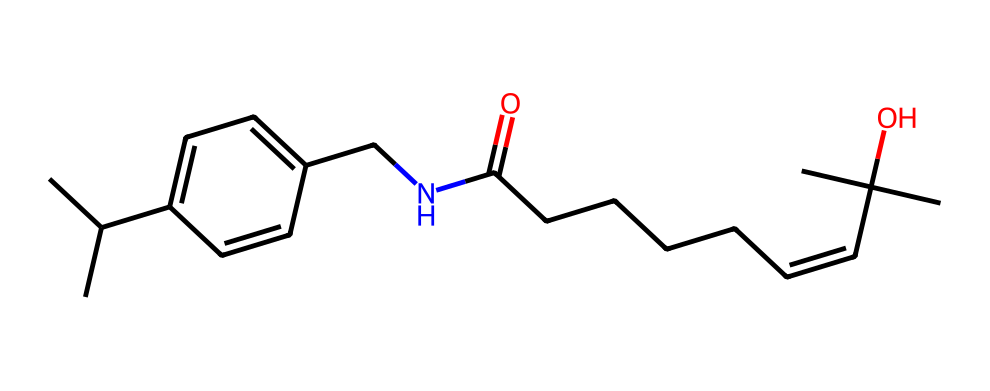What is the total number of carbon atoms in this compound? By inspecting the chemical structure represented in the SMILES, we can count the carbon (C) atoms. Each “C” in the SMILES indicates one carbon atom, and surrounding structures also indicate carbons in the ring and side chains. Upon counting, we find there are 17 carbon atoms total.
Answer: 17 How many nitrogen atoms does capsaicin contain? In the provided SMILES, the nitrogen (N) atom is explicitly represented. By examining the structure, we identify one nitrogen atom present in the amide functional group (CNC).
Answer: 1 Does this compound feature a double bond? The presence of a double bond can be determined by recognizing the “=” symbol in the SMILES notation. In capsaicin's structure, we see multiple “=” symbols indicating the presence of double bonds.
Answer: Yes Is capsaicin classified as a hypervalent compound? Hypervalent compounds are characterized by central atoms that can form more bonds than their usual valency allows. Capsaicin contains a nitrogen central atom in an amide configuration, and its structure indicates several atoms connected beyond the typical valency, classifying it as hypervalent.
Answer: Yes What type of functional group does capsaicin contain? By analyzing the structure, specifically looking for functional groups, we can see amides (CNC) and alcohols (C(C)(C)O) present. The primary functional groups identified are amide and alcohol.
Answer: Amide and alcohol How many rings are present in the molecular structure of capsaicin? To determine the number of rings, we analyze the cyclic structures indicated in the SMILES. In this case, there is one cyclic structure explicitly shown.
Answer: 1 What is the degree of saturation of capsaicin? The degree of saturation can be calculated based on the number of double and triple bonds present in the structure. Each double bond reduces saturation, and in capsaicin, there are 2 double bonds found. This suggests there is variation in saturation, indicating it's largely unsaturated.
Answer: 2 